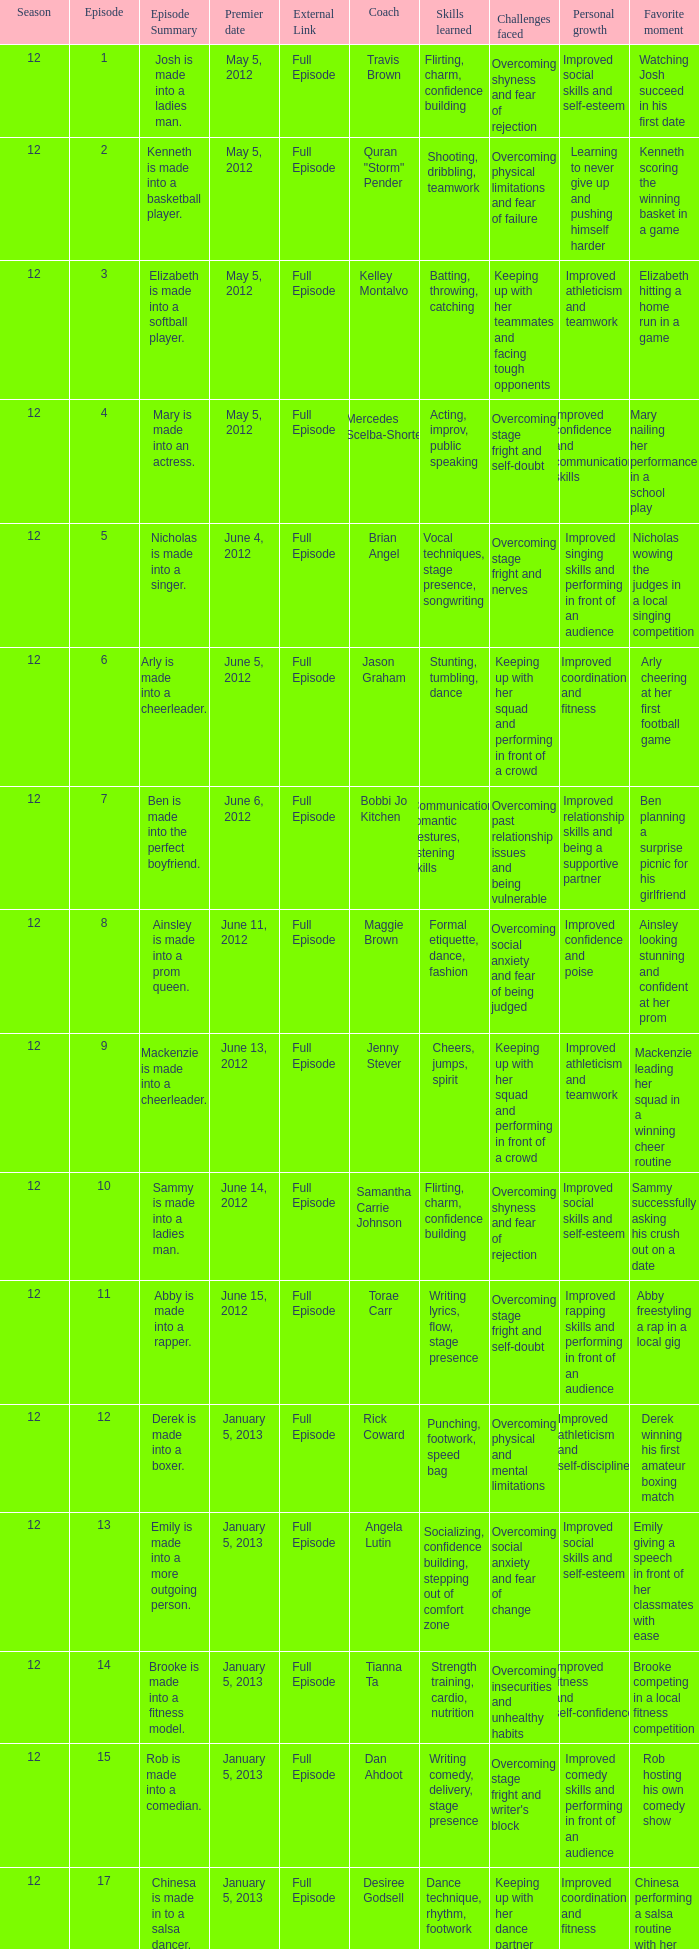Name the episode summary for travis brown Josh is made into a ladies man. 